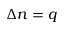<formula> <loc_0><loc_0><loc_500><loc_500>\Delta n = q</formula> 